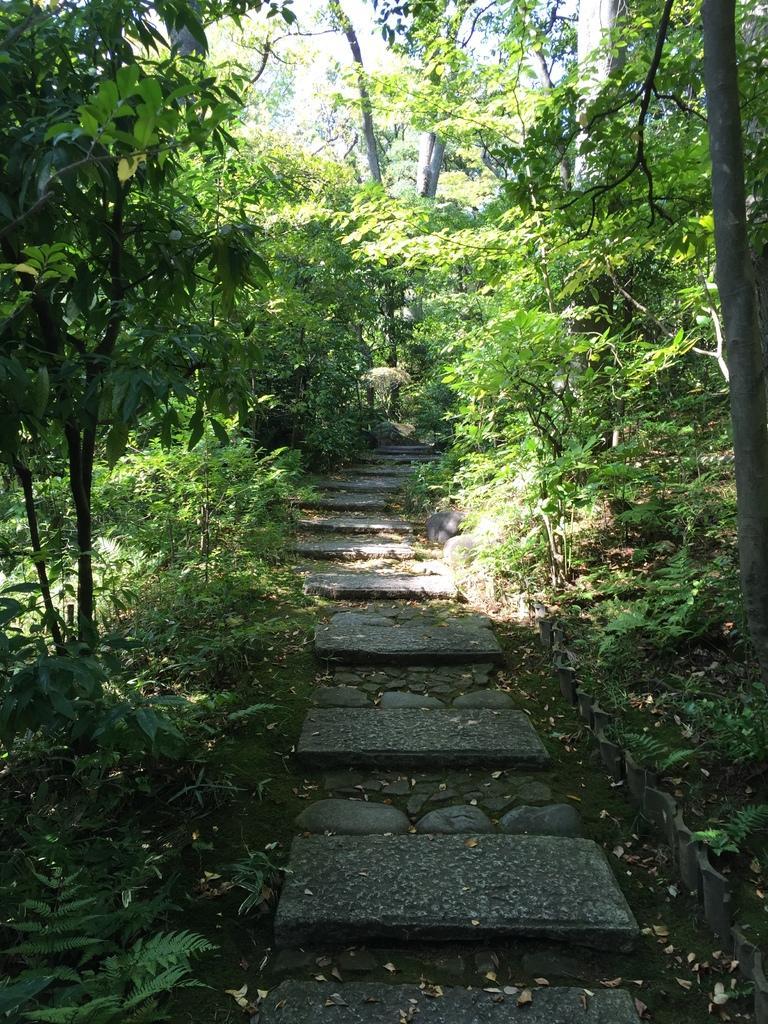Could you give a brief overview of what you see in this image? In this picture we can see a walking area in the center of the image and around there are many plants and trees. 